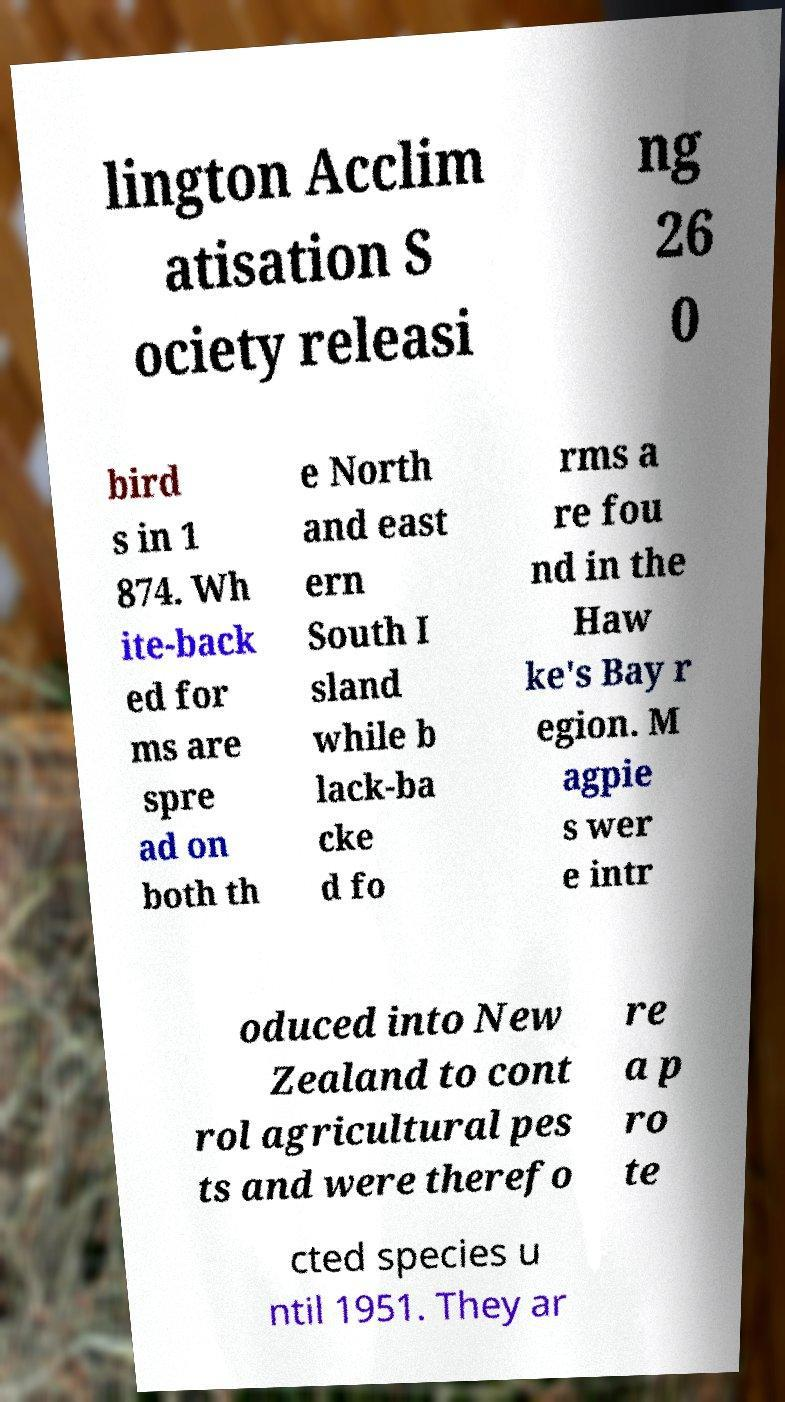What messages or text are displayed in this image? I need them in a readable, typed format. lington Acclim atisation S ociety releasi ng 26 0 bird s in 1 874. Wh ite-back ed for ms are spre ad on both th e North and east ern South I sland while b lack-ba cke d fo rms a re fou nd in the Haw ke's Bay r egion. M agpie s wer e intr oduced into New Zealand to cont rol agricultural pes ts and were therefo re a p ro te cted species u ntil 1951. They ar 